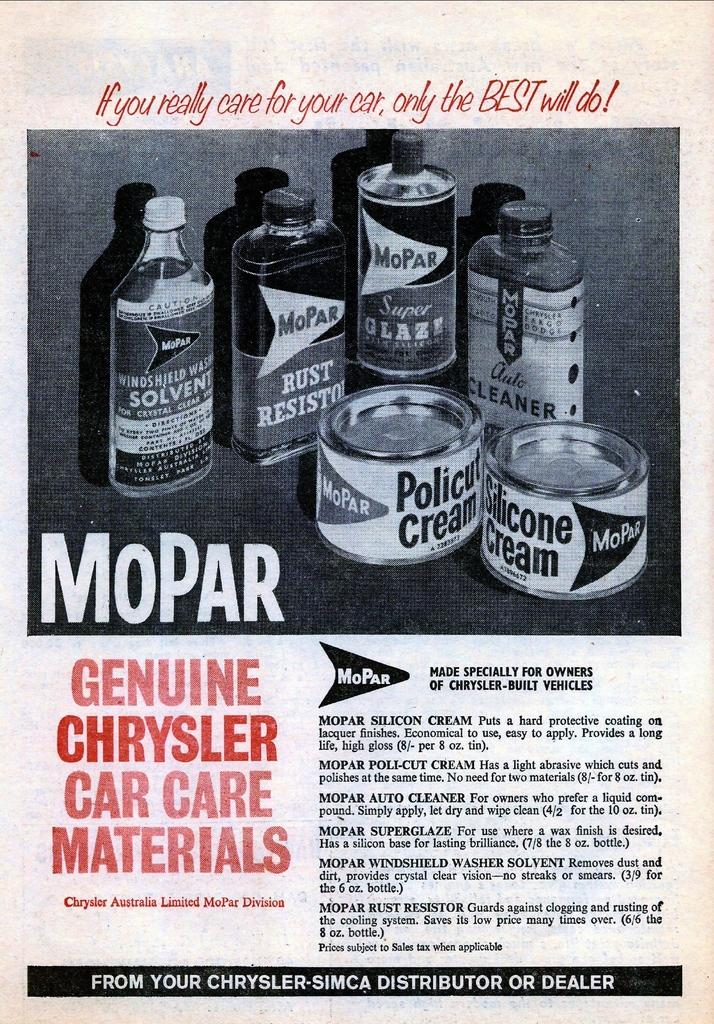<image>
Relay a brief, clear account of the picture shown. An old advertisement hawks various products from the Mopar line. 